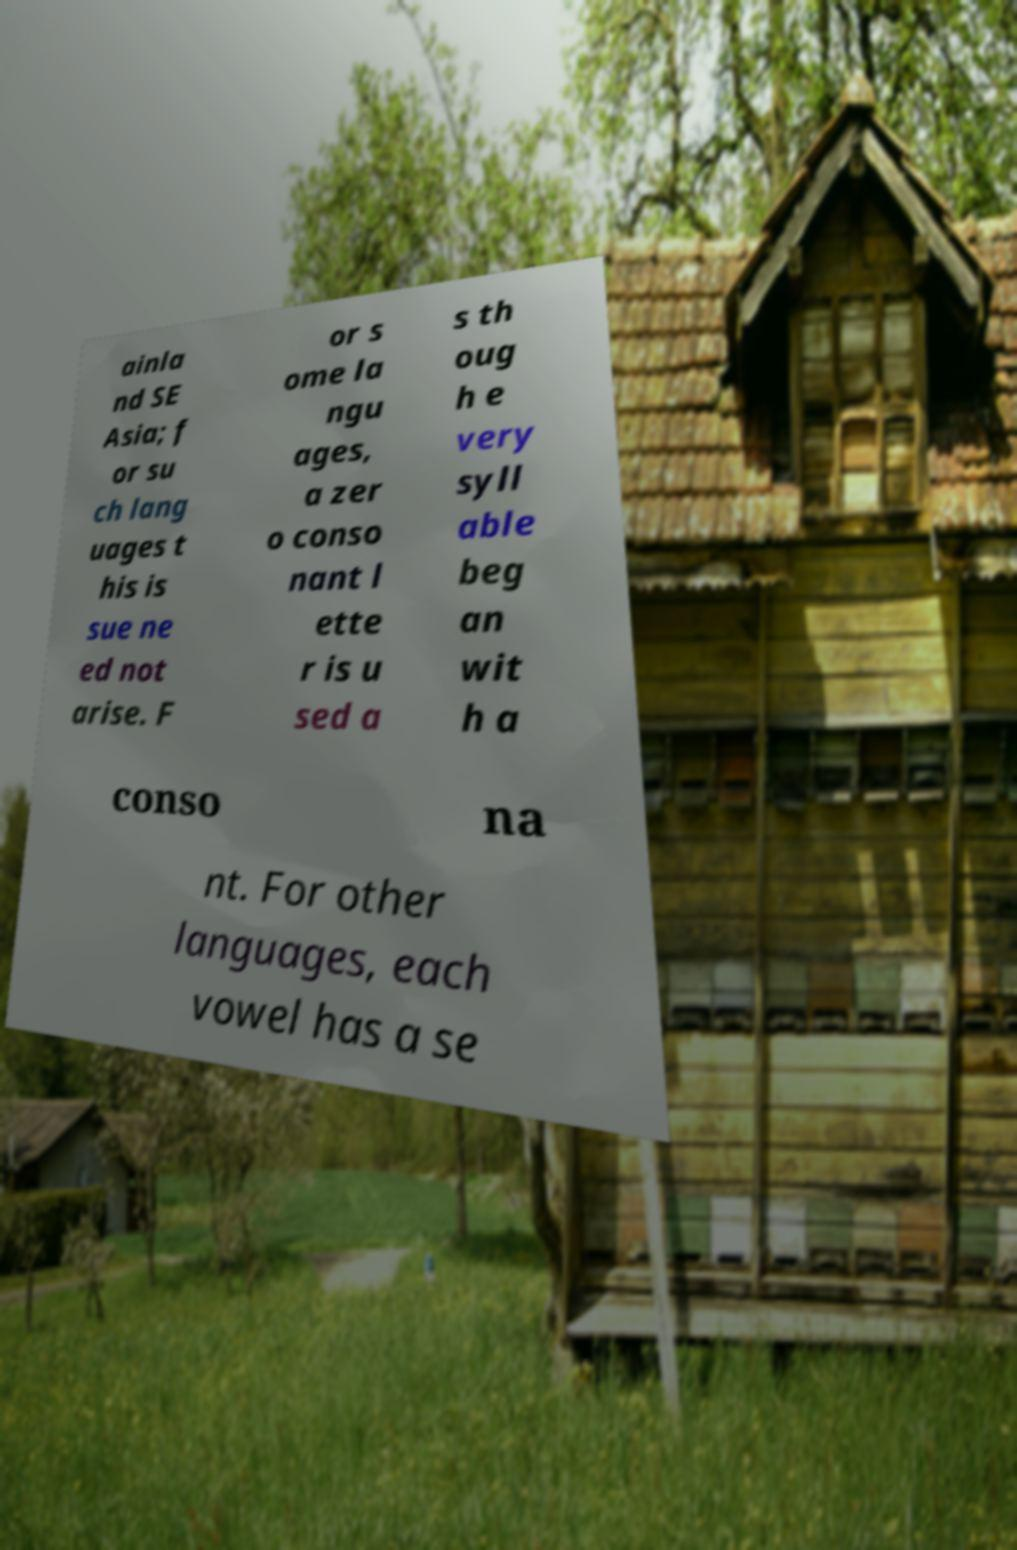For documentation purposes, I need the text within this image transcribed. Could you provide that? ainla nd SE Asia; f or su ch lang uages t his is sue ne ed not arise. F or s ome la ngu ages, a zer o conso nant l ette r is u sed a s th oug h e very syll able beg an wit h a conso na nt. For other languages, each vowel has a se 